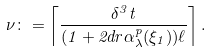Convert formula to latex. <formula><loc_0><loc_0><loc_500><loc_500>\nu \colon = \left \lceil \frac { \delta ^ { 3 } t } { ( 1 + 2 d r \alpha _ { \lambda } ^ { p } ( \xi _ { 1 } ) ) \ell } \right \rceil .</formula> 